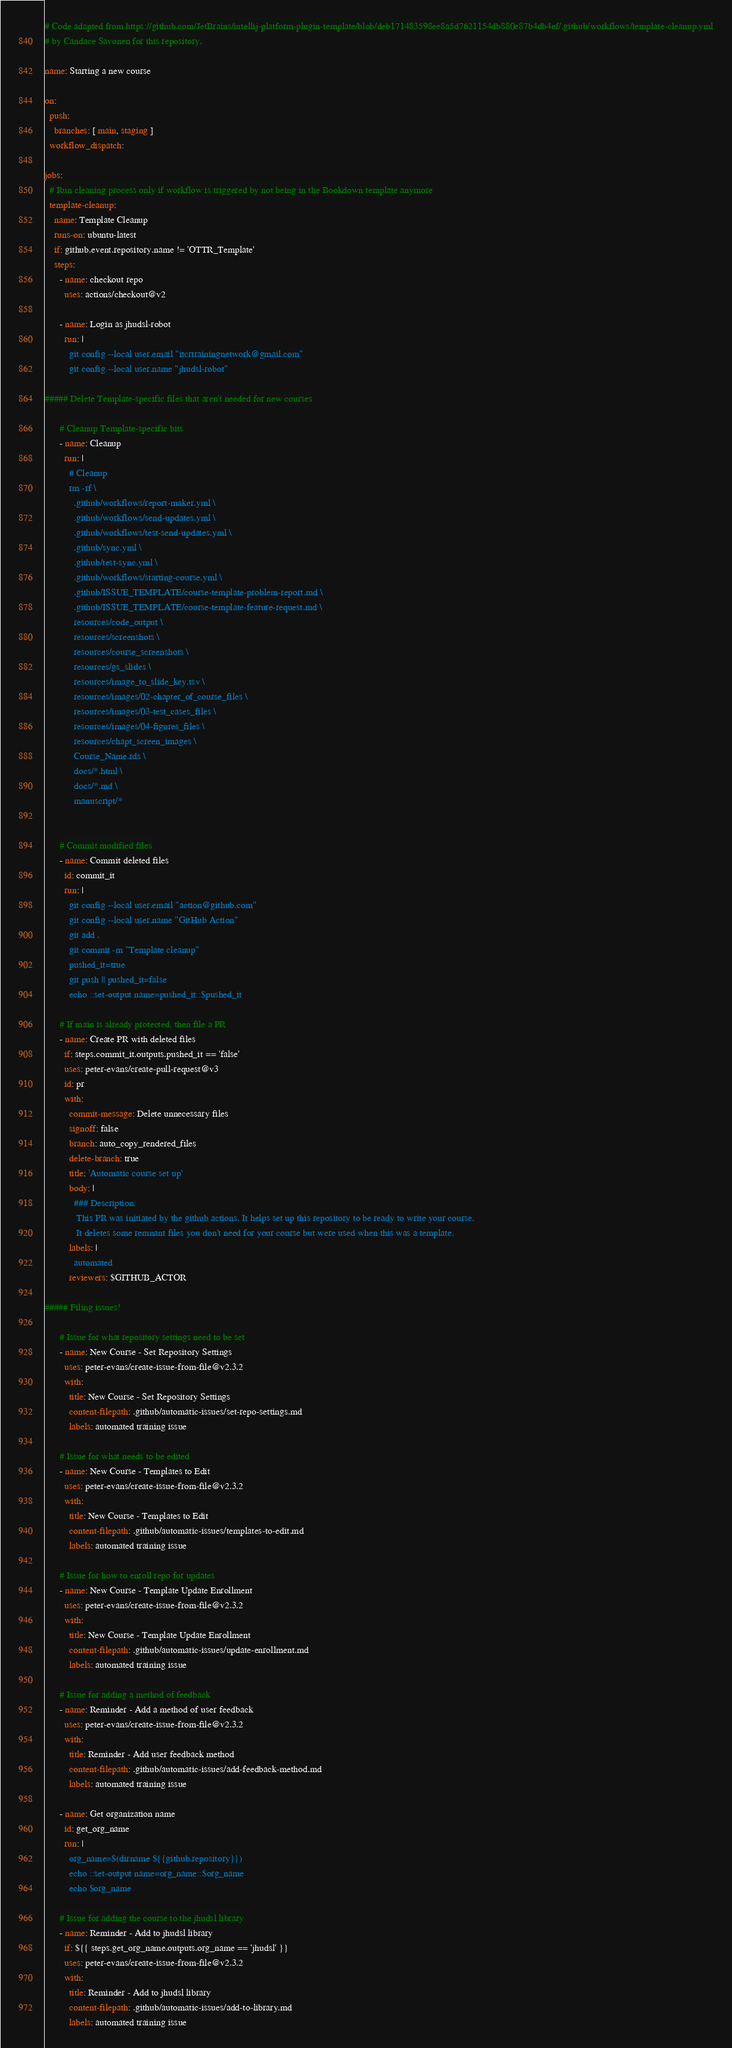<code> <loc_0><loc_0><loc_500><loc_500><_YAML_># Code adapted from https://github.com/JetBrains/intellij-platform-plugin-template/blob/deb171483598ee8a5d7621154db880e87b4db4ef/.github/workflows/template-cleanup.yml
# by Candace Savonen for this repository.

name: Starting a new course

on:
  push:
    branches: [ main, staging ]
  workflow_dispatch:

jobs:
  # Run cleaning process only if workflow is triggered by not being in the Bookdown template anymore
  template-cleanup:
    name: Template Cleanup
    runs-on: ubuntu-latest
    if: github.event.repository.name != 'OTTR_Template'
    steps:
      - name: checkout repo
        uses: actions/checkout@v2

      - name: Login as jhudsl-robot
        run: |
          git config --local user.email "itcrtrainingnetwork@gmail.com"
          git config --local user.name "jhudsl-robot"

##### Delete Template-specific files that aren't needed for new courses

      # Cleanup Template-specific bits
      - name: Cleanup
        run: |
          # Cleanup
          rm -rf \
            .github/workflows/report-maker.yml \
            .github/workflows/send-updates.yml \
            .github/workflows/test-send-updates.yml \
            .github/sync.yml \
            .github/test-sync.yml \
            .github/workflows/starting-course.yml \
            .github/ISSUE_TEMPLATE/course-template-problem-report.md \
            .github/ISSUE_TEMPLATE/course-template-feature-request.md \
            resources/code_output \
            resources/screenshots \
            resources/course_screenshots \
            resources/gs_slides \
            resources/image_to_slide_key.tsv \
            resources/images/02-chapter_of_course_files \
            resources/images/03-test_cases_files \
            resources/images/04-figures_files \
            resources/chapt_screen_images \
            Course_Name.rds \
            docs/*.html \
            docs/*.md \
            manuscript/*


      # Commit modified files
      - name: Commit deleted files
        id: commit_it
        run: |
          git config --local user.email "action@github.com"
          git config --local user.name "GitHub Action"
          git add .
          git commit -m "Template cleanup"
          pushed_it=true
          git push || pushed_it=false
          echo ::set-output name=pushed_it::$pushed_it

      # If main is already protected, then file a PR
      - name: Create PR with deleted files
        if: steps.commit_it.outputs.pushed_it == 'false'
        uses: peter-evans/create-pull-request@v3
        id: pr
        with:
          commit-message: Delete unnecessary files
          signoff: false
          branch: auto_copy_rendered_files
          delete-branch: true
          title: 'Automatic course set up'
          body: |
            ### Description:
             This PR was initiated by the github actions. It helps set up this repository to be ready to write your course.
             It deletes some remnant files you don't need for your course but were used when this was a template.
          labels: |
            automated
          reviewers: $GITHUB_ACTOR

##### Filing issues!

      # Issue for what repository settings need to be set
      - name: New Course - Set Repository Settings
        uses: peter-evans/create-issue-from-file@v2.3.2
        with:
          title: New Course - Set Repository Settings
          content-filepath: .github/automatic-issues/set-repo-settings.md
          labels: automated training issue

      # Issue for what needs to be edited
      - name: New Course - Templates to Edit
        uses: peter-evans/create-issue-from-file@v2.3.2
        with:
          title: New Course - Templates to Edit
          content-filepath: .github/automatic-issues/templates-to-edit.md
          labels: automated training issue

      # Issue for how to enroll repo for updates
      - name: New Course - Template Update Enrollment
        uses: peter-evans/create-issue-from-file@v2.3.2
        with:
          title: New Course - Template Update Enrollment
          content-filepath: .github/automatic-issues/update-enrollment.md
          labels: automated training issue

      # Issue for adding a method of feedback
      - name: Reminder - Add a method of user feedback
        uses: peter-evans/create-issue-from-file@v2.3.2
        with:
          title: Reminder - Add user feedback method
          content-filepath: .github/automatic-issues/add-feedback-method.md
          labels: automated training issue

      - name: Get organization name
        id: get_org_name
        run: |
          org_name=$(dirname ${{github.repository}})
          echo ::set-output name=org_name::$org_name
          echo $org_name

      # Issue for adding the course to the jhudsl library
      - name: Reminder - Add to jhudsl library
        if: ${{ steps.get_org_name.outputs.org_name == 'jhudsl' }}
        uses: peter-evans/create-issue-from-file@v2.3.2
        with:
          title: Reminder - Add to jhudsl library
          content-filepath: .github/automatic-issues/add-to-library.md
          labels: automated training issue
</code> 